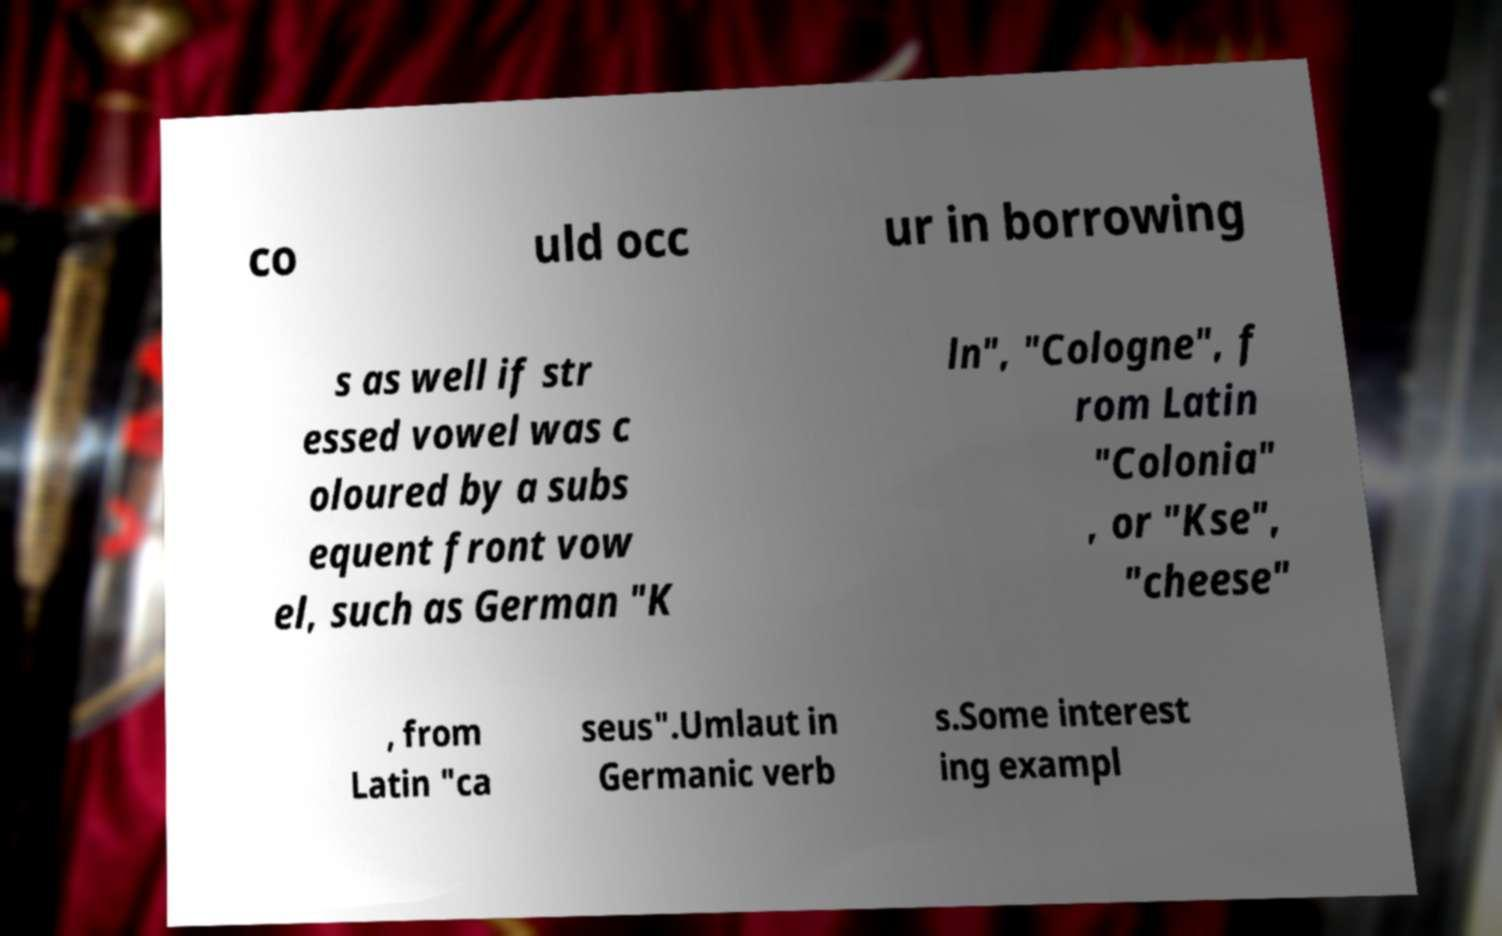What messages or text are displayed in this image? I need them in a readable, typed format. co uld occ ur in borrowing s as well if str essed vowel was c oloured by a subs equent front vow el, such as German "K ln", "Cologne", f rom Latin "Colonia" , or "Kse", "cheese" , from Latin "ca seus".Umlaut in Germanic verb s.Some interest ing exampl 